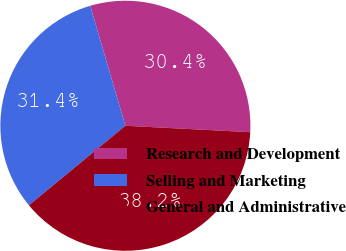Convert chart to OTSL. <chart><loc_0><loc_0><loc_500><loc_500><pie_chart><fcel>Research and Development<fcel>Selling and Marketing<fcel>General and Administrative<nl><fcel>30.36%<fcel>31.44%<fcel>38.21%<nl></chart> 